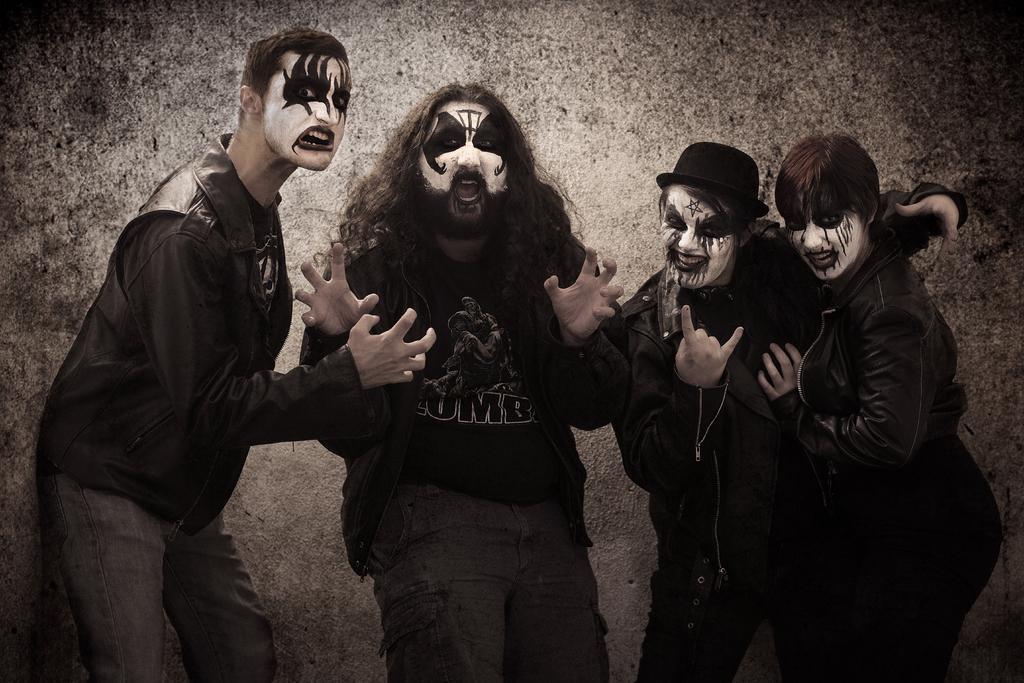Describe this image in one or two sentences. In this image, we can see some people standing and they have face paintings on the faces, in the background we can see the wall. 